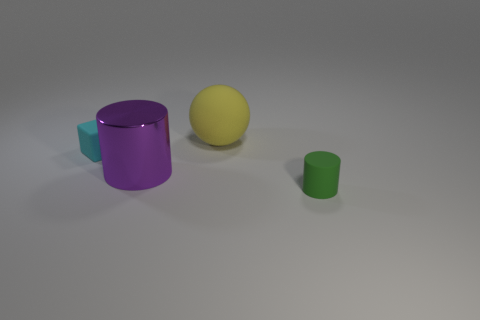Is there anything else that is the same material as the purple object?
Offer a very short reply. No. There is a thing that is behind the cyan thing behind the tiny thing that is right of the purple object; how big is it?
Ensure brevity in your answer.  Large. Does the purple thing that is behind the green matte cylinder have the same shape as the tiny thing to the right of the tiny cyan rubber thing?
Make the answer very short. Yes. The other green thing that is the same shape as the metal thing is what size?
Your answer should be very brief. Small. How many other large yellow spheres have the same material as the large yellow ball?
Your response must be concise. 0. What is the material of the green thing?
Keep it short and to the point. Rubber. What shape is the big purple metal object that is on the left side of the small thing in front of the tiny cyan matte thing?
Keep it short and to the point. Cylinder. What shape is the small thing that is left of the small green matte cylinder?
Make the answer very short. Cube. The tiny block is what color?
Offer a terse response. Cyan. What number of big yellow objects are to the left of the green rubber thing right of the tiny cyan thing?
Give a very brief answer. 1. 